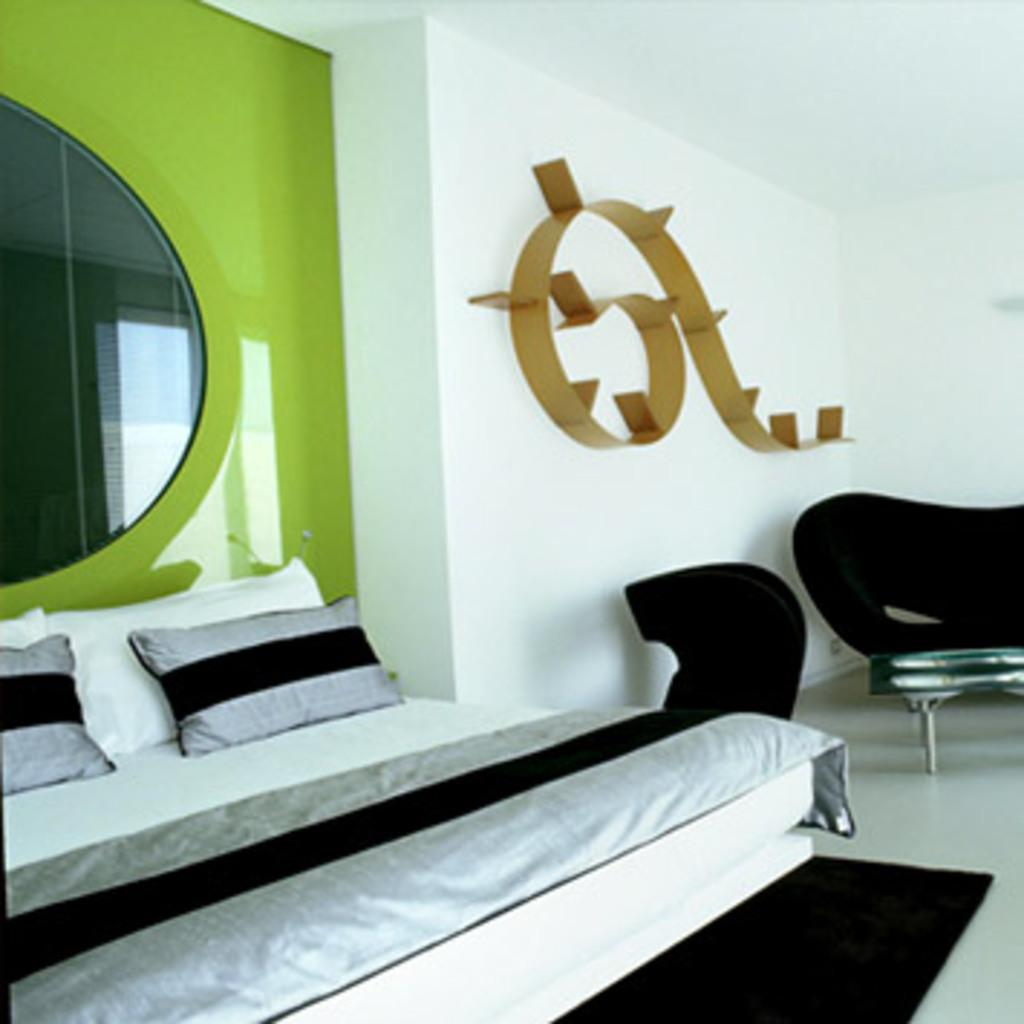What type of furniture is present in the image? There is a bed and a couch in the image. What can be seen on the wall in the image? There is a mirror and a design on the wall in the image. What type of bread is being used as a decoration on the bed in the image? There is no bread present in the image; it only features a bed, a couch, a mirror, and a design on the wall. 